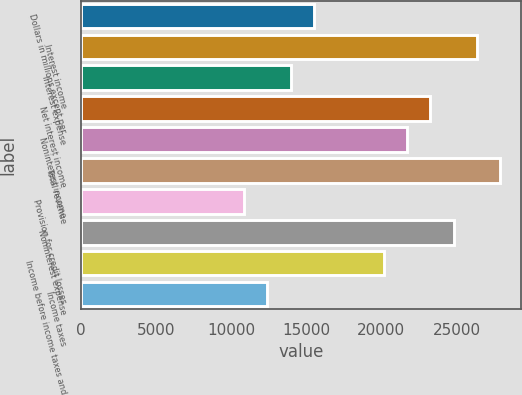<chart> <loc_0><loc_0><loc_500><loc_500><bar_chart><fcel>Dollars in millions except per<fcel>Interest income<fcel>Interest expense<fcel>Net interest income<fcel>Noninterest income<fcel>Total revenue<fcel>Provision for credit losses<fcel>Noninterest expense<fcel>Income before income taxes and<fcel>Income taxes<nl><fcel>15512<fcel>26369.3<fcel>13961<fcel>23267.2<fcel>21716.2<fcel>27920.3<fcel>10858.9<fcel>24818.2<fcel>20165.1<fcel>12409.9<nl></chart> 